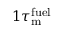Convert formula to latex. <formula><loc_0><loc_0><loc_500><loc_500>1 \tau _ { m } ^ { f u e l }</formula> 